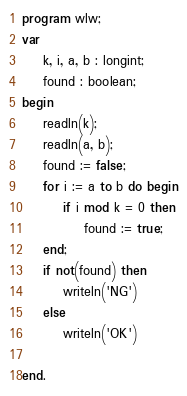<code> <loc_0><loc_0><loc_500><loc_500><_Pascal_>program wlw;
var
    k, i, a, b : longint;
    found : boolean;
begin
    readln(k);
    readln(a, b);
    found := false;
    for i := a to b do begin
        if i mod k = 0 then
            found := true;
    end;
    if not(found) then
        writeln('NG')
    else 
        writeln('OK')
    
end.</code> 